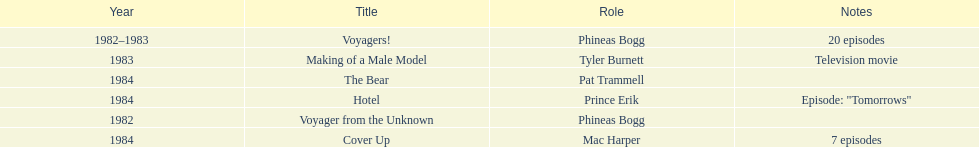In what year did he portray mac harper and pat trammell? 1984. 